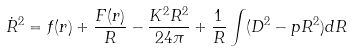Convert formula to latex. <formula><loc_0><loc_0><loc_500><loc_500>\dot { R } ^ { 2 } = f ( r ) + \frac { F ( r ) } { R } - \frac { K ^ { 2 } R ^ { 2 } } { 2 4 \pi } + \frac { 1 } { R } \int ( D ^ { 2 } - p R ^ { 2 } ) d R</formula> 